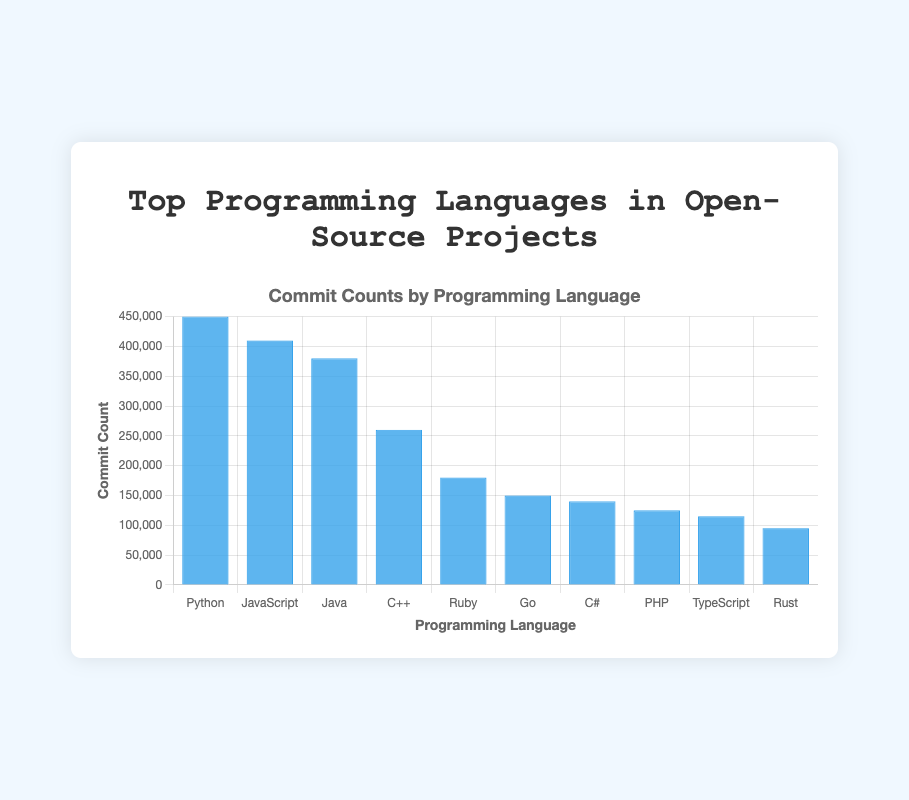Which programming language has the highest commit count? The figure shows that the bar for Python is the tallest, indicating it has the highest commit count.
Answer: Python What is the difference in commit counts between JavaScript and Java? According to the figure, JavaScript has 410,000 commits, and Java has 380,000 commits. The difference is 410,000 - 380,000.
Answer: 30,000 Which programming language has fewer commits, Ruby or Go? The figure indicates that the bar for Ruby is taller than the bar for Go. Ruby has 180,000 commits, and Go has 150,000 commits.
Answer: Go Is the commit count of Python greater than the combined commit counts of C# and PHP? Python has 450,000 commits. C# has 140,000 commits and PHP has 125,000 commits. Combined, C# and PHP have 140,000 + 125,000 = 265,000 commits. Since 450,000 is greater than 265,000, the answer is yes.
Answer: Yes How many more commits does C++ have than Rust? The figure shows C++ has 260,000 commits and Rust has 95,000 commits. The difference is 260,000 - 95,000.
Answer: 165,000 What are the total commit counts for the top 3 programming languages? The top three languages are Python, JavaScript, and Java. Their commit counts are 450,000, 410,000, and 380,000 respectively. The total is 450,000 + 410,000 + 380,000.
Answer: 1,240,000 What is the average commit count for the given programming languages? To find the average, sum all the commit counts and divide by the number of languages. The total commit counts are 450,000 + 410,000 + 380,000 + 260,000 + 180,000 + 150,000 + 140,000 + 125,000 + 115,000 + 95,000 = 2,305,000. There are 10 languages, so the average is 2,305,000 / 10.
Answer: 230,500 Which language has a commit count closest to 100,000? The figure shows that Rust has a commit count of 95,000, which is closest to 100,000 among all languages.
Answer: Rust What percentage of the total commits does PHP contribute? First, calculate the total number of commits, which is 2,305,000. PHP has 125,000 commits. The percentage is (125,000 / 2,305,000) * 100.
Answer: 5.42% Which programming language has the shortest bar and what is its commit count? The figure shows that Rust has the shortest bar with a commit count of 95,000.
Answer: Rust, 95,000 